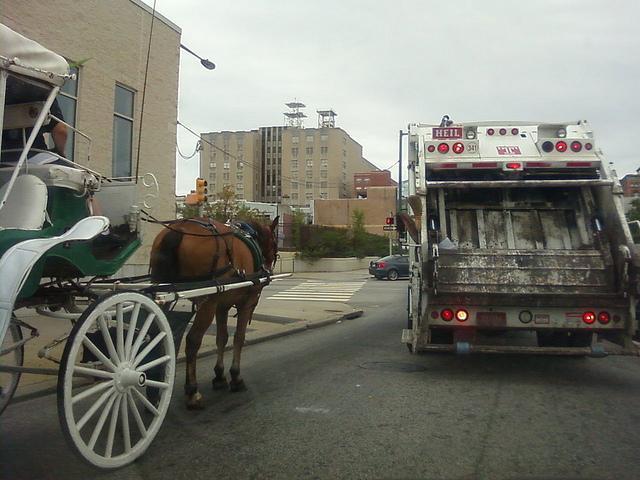How many cars are in the picture?
Give a very brief answer. 1. How many oxen are in the photo?
Give a very brief answer. 0. How many cars are behind the horse carriage?
Give a very brief answer. 0. How many trucks can you see?
Give a very brief answer. 1. 